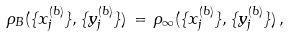Convert formula to latex. <formula><loc_0><loc_0><loc_500><loc_500>\rho _ { B } ( \{ x _ { j } ^ { ( b ) } \} , \{ y _ { j } ^ { ( b ) } \} ) \, = \, \rho _ { \infty } ( \{ x _ { j } ^ { ( b ) } \} , \{ y _ { j } ^ { ( b ) } \} ) \, ,</formula> 